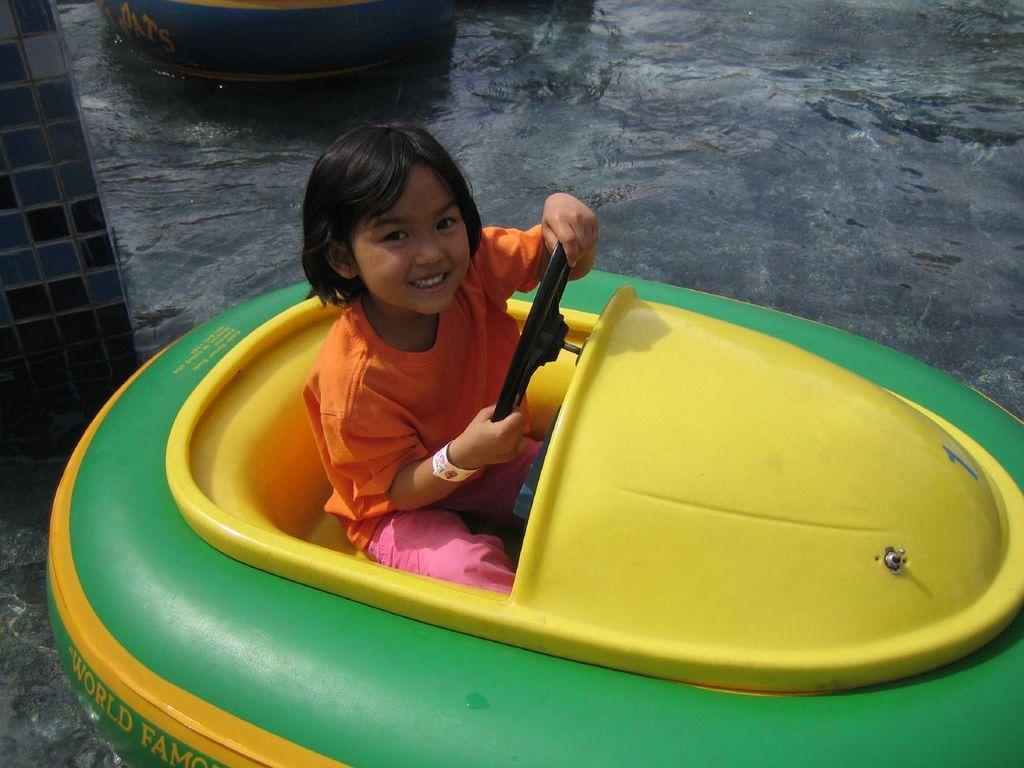Describe this image in one or two sentences. In the center of the image, we can see a kid sitting in the paddle boat and we can see an object and an other boat. At the bottom, there is water. 